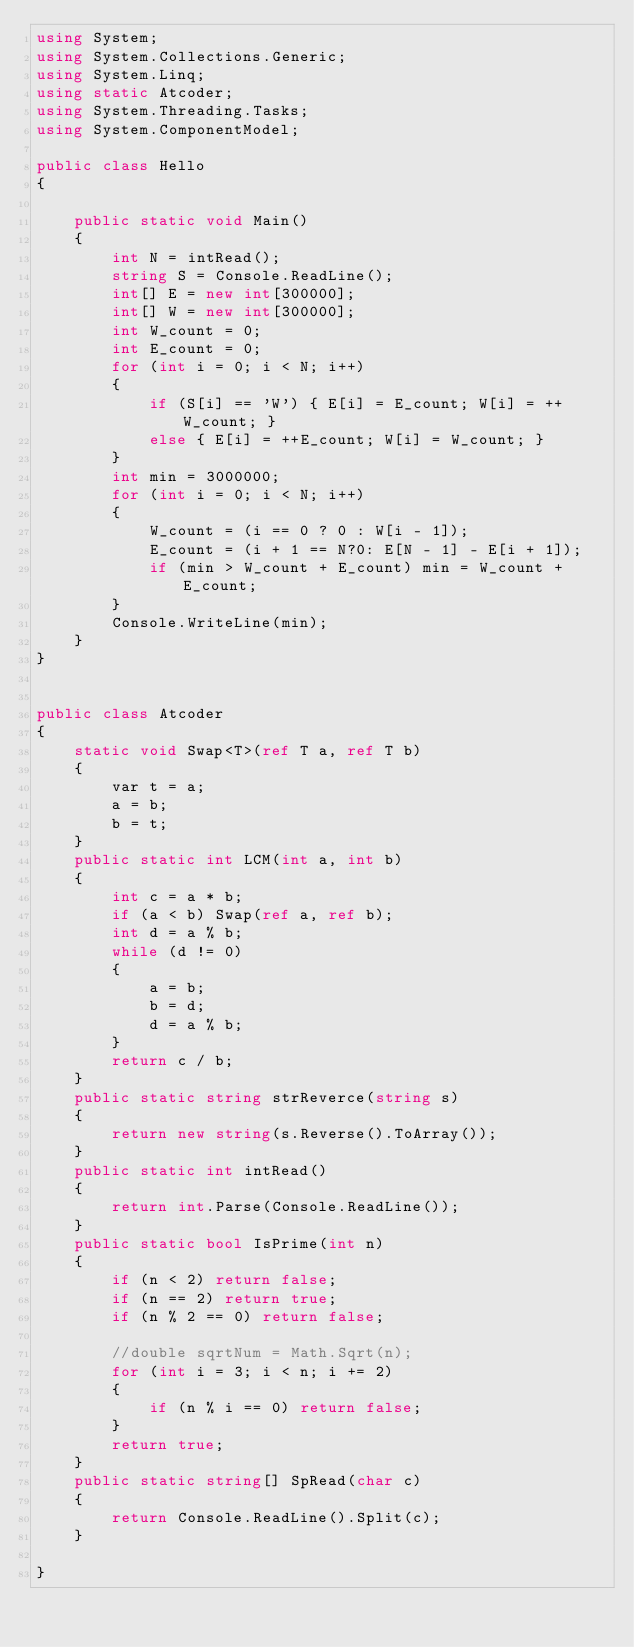<code> <loc_0><loc_0><loc_500><loc_500><_C#_>using System;
using System.Collections.Generic;
using System.Linq;
using static Atcoder;
using System.Threading.Tasks;
using System.ComponentModel;

public class Hello
{

    public static void Main()
    {
        int N = intRead();
        string S = Console.ReadLine();
        int[] E = new int[300000];
        int[] W = new int[300000];
        int W_count = 0;
        int E_count = 0;
        for (int i = 0; i < N; i++)
        {
            if (S[i] == 'W') { E[i] = E_count; W[i] = ++W_count; }
            else { E[i] = ++E_count; W[i] = W_count; }
        }
        int min = 3000000;
        for (int i = 0; i < N; i++)
        {
            W_count = (i == 0 ? 0 : W[i - 1]);
            E_count = (i + 1 == N?0: E[N - 1] - E[i + 1]);
            if (min > W_count + E_count) min = W_count + E_count;
        }
        Console.WriteLine(min);
    }
}


public class Atcoder
{
    static void Swap<T>(ref T a, ref T b)
    {
        var t = a;
        a = b;
        b = t;
    }
    public static int LCM(int a, int b)
    {
        int c = a * b;
        if (a < b) Swap(ref a, ref b);
        int d = a % b;
        while (d != 0)
        {
            a = b;
            b = d;
            d = a % b;
        }
        return c / b;
    }
    public static string strReverce(string s)
    {
        return new string(s.Reverse().ToArray());
    }
    public static int intRead()
    {
        return int.Parse(Console.ReadLine());
    }
    public static bool IsPrime(int n)
    {
        if (n < 2) return false;
        if (n == 2) return true;
        if (n % 2 == 0) return false;

        //double sqrtNum = Math.Sqrt(n);
        for (int i = 3; i < n; i += 2)
        {
            if (n % i == 0) return false;
        }
        return true;
    }
    public static string[] SpRead(char c)
    {
        return Console.ReadLine().Split(c);
    }

}
</code> 